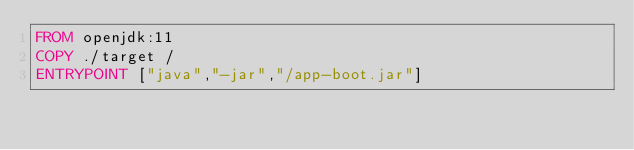Convert code to text. <code><loc_0><loc_0><loc_500><loc_500><_Dockerfile_>FROM openjdk:11
COPY ./target /
ENTRYPOINT ["java","-jar","/app-boot.jar"]
</code> 